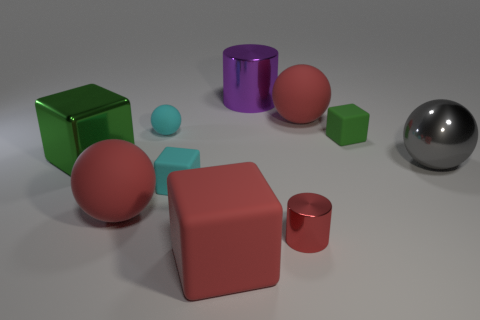Is the small shiny cylinder the same color as the large matte block?
Your response must be concise. Yes. Are there any other things that are the same color as the big metallic cylinder?
Ensure brevity in your answer.  No. What shape is the matte object that is the same color as the tiny ball?
Your answer should be compact. Cube. How big is the shiny cylinder behind the green rubber thing?
Offer a terse response. Large. The red metallic object that is the same size as the cyan sphere is what shape?
Provide a short and direct response. Cylinder. Is the large block that is behind the small red object made of the same material as the green thing on the right side of the large purple metallic object?
Ensure brevity in your answer.  No. There is a large object that is behind the red matte object on the right side of the red metallic cylinder; what is it made of?
Give a very brief answer. Metal. There is a red shiny cylinder to the left of the red rubber thing that is behind the green thing that is right of the big red cube; what size is it?
Offer a terse response. Small. Does the purple shiny cylinder have the same size as the cyan rubber ball?
Make the answer very short. No. There is a green object that is to the left of the large purple metallic object; is it the same shape as the green thing that is right of the purple cylinder?
Provide a short and direct response. Yes. 